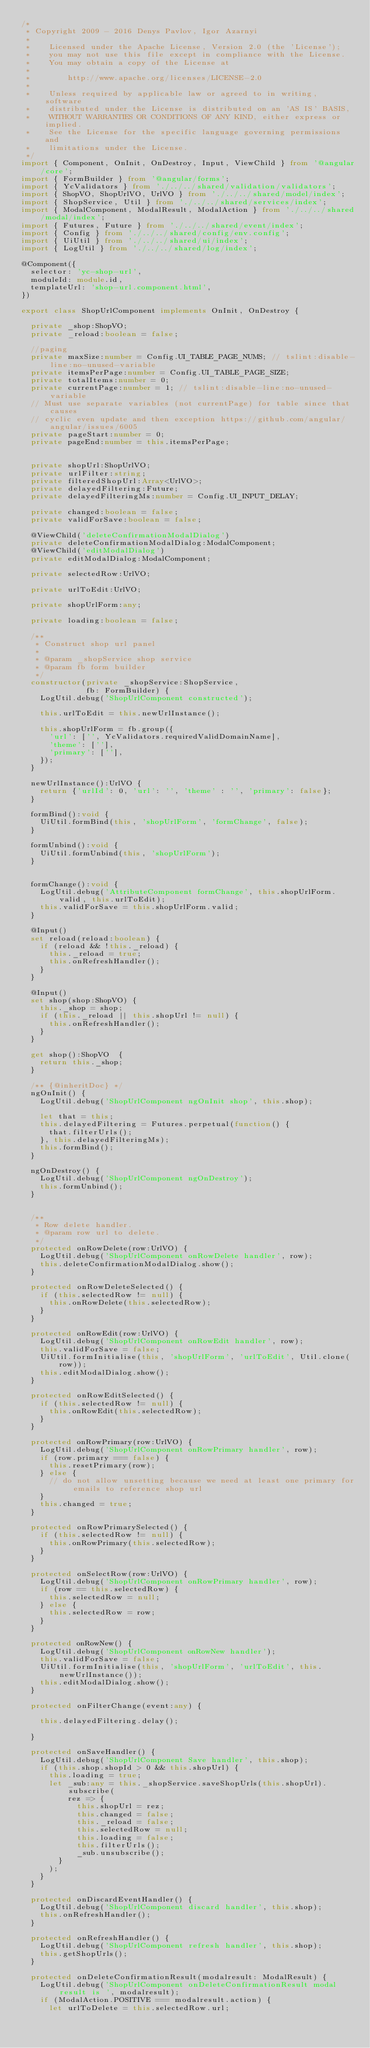<code> <loc_0><loc_0><loc_500><loc_500><_TypeScript_>/*
 * Copyright 2009 - 2016 Denys Pavlov, Igor Azarnyi
 *
 *    Licensed under the Apache License, Version 2.0 (the 'License');
 *    you may not use this file except in compliance with the License.
 *    You may obtain a copy of the License at
 *
 *        http://www.apache.org/licenses/LICENSE-2.0
 *
 *    Unless required by applicable law or agreed to in writing, software
 *    distributed under the License is distributed on an 'AS IS' BASIS,
 *    WITHOUT WARRANTIES OR CONDITIONS OF ANY KIND, either express or implied.
 *    See the License for the specific language governing permissions and
 *    limitations under the License.
 */
import { Component, OnInit, OnDestroy, Input, ViewChild } from '@angular/core';
import { FormBuilder } from '@angular/forms';
import { YcValidators } from './../../shared/validation/validators';
import { ShopVO, ShopUrlVO, UrlVO } from './../../shared/model/index';
import { ShopService, Util } from './../../shared/services/index';
import { ModalComponent, ModalResult, ModalAction } from './../../shared/modal/index';
import { Futures, Future } from './../../shared/event/index';
import { Config } from './../../shared/config/env.config';
import { UiUtil } from './../../shared/ui/index';
import { LogUtil } from './../../shared/log/index';

@Component({
  selector: 'yc-shop-url',
  moduleId: module.id,
  templateUrl: 'shop-url.component.html',
})

export class ShopUrlComponent implements OnInit, OnDestroy {

  private _shop:ShopVO;
  private _reload:boolean = false;

  //paging
  private maxSize:number = Config.UI_TABLE_PAGE_NUMS; // tslint:disable-line:no-unused-variable
  private itemsPerPage:number = Config.UI_TABLE_PAGE_SIZE;
  private totalItems:number = 0;
  private currentPage:number = 1; // tslint:disable-line:no-unused-variable
  // Must use separate variables (not currentPage) for table since that causes
  // cyclic even update and then exception https://github.com/angular/angular/issues/6005
  private pageStart:number = 0;
  private pageEnd:number = this.itemsPerPage;


  private shopUrl:ShopUrlVO;
  private urlFilter:string;
  private filteredShopUrl:Array<UrlVO>;
  private delayedFiltering:Future;
  private delayedFilteringMs:number = Config.UI_INPUT_DELAY;

  private changed:boolean = false;
  private validForSave:boolean = false;

  @ViewChild('deleteConfirmationModalDialog')
  private deleteConfirmationModalDialog:ModalComponent;
  @ViewChild('editModalDialog')
  private editModalDialog:ModalComponent;

  private selectedRow:UrlVO;

  private urlToEdit:UrlVO;

  private shopUrlForm:any;

  private loading:boolean = false;

  /**
   * Construct shop url panel
   *
   * @param _shopService shop service
   * @param fb form builder
   */
  constructor(private _shopService:ShopService,
              fb: FormBuilder) {
    LogUtil.debug('ShopUrlComponent constructed');

    this.urlToEdit = this.newUrlInstance();

    this.shopUrlForm = fb.group({
      'url': ['', YcValidators.requiredValidDomainName],
      'theme': [''],
      'primary': [''],
    });
  }

  newUrlInstance():UrlVO {
    return {'urlId': 0, 'url': '', 'theme' : '', 'primary': false};
  }

  formBind():void {
    UiUtil.formBind(this, 'shopUrlForm', 'formChange', false);
  }

  formUnbind():void {
    UiUtil.formUnbind(this, 'shopUrlForm');
  }


  formChange():void {
    LogUtil.debug('AttributeComponent formChange', this.shopUrlForm.valid, this.urlToEdit);
    this.validForSave = this.shopUrlForm.valid;
  }

  @Input()
  set reload(reload:boolean) {
    if (reload && !this._reload) {
      this._reload = true;
      this.onRefreshHandler();
    }
  }

  @Input()
  set shop(shop:ShopVO) {
    this._shop = shop;
    if (this._reload || this.shopUrl != null) {
      this.onRefreshHandler();
    }
  }

  get shop():ShopVO  {
    return this._shop;
  }

  /** {@inheritDoc} */
  ngOnInit() {
    LogUtil.debug('ShopUrlComponent ngOnInit shop', this.shop);

    let that = this;
    this.delayedFiltering = Futures.perpetual(function() {
      that.filterUrls();
    }, this.delayedFilteringMs);
    this.formBind();
  }

  ngOnDestroy() {
    LogUtil.debug('ShopUrlComponent ngOnDestroy');
    this.formUnbind();
  }


  /**
   * Row delete handler.
   * @param row url to delete.
   */
  protected onRowDelete(row:UrlVO) {
    LogUtil.debug('ShopUrlComponent onRowDelete handler', row);
    this.deleteConfirmationModalDialog.show();
  }

  protected onRowDeleteSelected() {
    if (this.selectedRow != null) {
      this.onRowDelete(this.selectedRow);
    }
  }

  protected onRowEdit(row:UrlVO) {
    LogUtil.debug('ShopUrlComponent onRowEdit handler', row);
    this.validForSave = false;
    UiUtil.formInitialise(this, 'shopUrlForm', 'urlToEdit', Util.clone(row));
    this.editModalDialog.show();
  }

  protected onRowEditSelected() {
    if (this.selectedRow != null) {
      this.onRowEdit(this.selectedRow);
    }
  }

  protected onRowPrimary(row:UrlVO) {
    LogUtil.debug('ShopUrlComponent onRowPrimary handler', row);
    if (row.primary === false) {
      this.resetPrimary(row);
    } else {
      // do not allow unsetting because we need at least one primary for emails to reference shop url
    }
    this.changed = true;
  }

  protected onRowPrimarySelected() {
    if (this.selectedRow != null) {
      this.onRowPrimary(this.selectedRow);
    }
  }

  protected onSelectRow(row:UrlVO) {
    LogUtil.debug('ShopUrlComponent onRowPrimary handler', row);
    if (row == this.selectedRow) {
      this.selectedRow = null;
    } else {
      this.selectedRow = row;
    }
  }

  protected onRowNew() {
    LogUtil.debug('ShopUrlComponent onRowNew handler');
    this.validForSave = false;
    UiUtil.formInitialise(this, 'shopUrlForm', 'urlToEdit', this.newUrlInstance());
    this.editModalDialog.show();
  }

  protected onFilterChange(event:any) {

    this.delayedFiltering.delay();

  }

  protected onSaveHandler() {
    LogUtil.debug('ShopUrlComponent Save handler', this.shop);
    if (this.shop.shopId > 0 && this.shopUrl) {
      this.loading = true;
      let _sub:any = this._shopService.saveShopUrls(this.shopUrl).subscribe(
          rez => {
            this.shopUrl = rez;
            this.changed = false;
            this._reload = false;
            this.selectedRow = null;
            this.loading = false;
            this.filterUrls();
            _sub.unsubscribe();
        }
      );
    }
  }

  protected onDiscardEventHandler() {
    LogUtil.debug('ShopUrlComponent discard handler', this.shop);
    this.onRefreshHandler();
  }

  protected onRefreshHandler() {
    LogUtil.debug('ShopUrlComponent refresh handler', this.shop);
    this.getShopUrls();
  }

  protected onDeleteConfirmationResult(modalresult: ModalResult) {
    LogUtil.debug('ShopUrlComponent onDeleteConfirmationResult modal result is ', modalresult);
    if (ModalAction.POSITIVE === modalresult.action) {
      let urlToDelete = this.selectedRow.url;</code> 